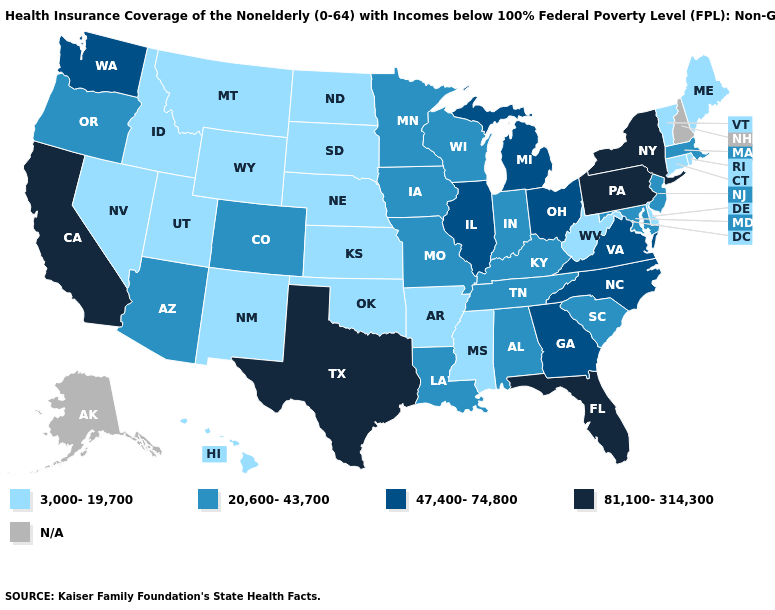What is the value of West Virginia?
Short answer required. 3,000-19,700. Name the states that have a value in the range 20,600-43,700?
Short answer required. Alabama, Arizona, Colorado, Indiana, Iowa, Kentucky, Louisiana, Maryland, Massachusetts, Minnesota, Missouri, New Jersey, Oregon, South Carolina, Tennessee, Wisconsin. Name the states that have a value in the range 20,600-43,700?
Keep it brief. Alabama, Arizona, Colorado, Indiana, Iowa, Kentucky, Louisiana, Maryland, Massachusetts, Minnesota, Missouri, New Jersey, Oregon, South Carolina, Tennessee, Wisconsin. What is the lowest value in the West?
Answer briefly. 3,000-19,700. Which states have the highest value in the USA?
Short answer required. California, Florida, New York, Pennsylvania, Texas. Does Mississippi have the lowest value in the South?
Keep it brief. Yes. Which states have the lowest value in the USA?
Concise answer only. Arkansas, Connecticut, Delaware, Hawaii, Idaho, Kansas, Maine, Mississippi, Montana, Nebraska, Nevada, New Mexico, North Dakota, Oklahoma, Rhode Island, South Dakota, Utah, Vermont, West Virginia, Wyoming. How many symbols are there in the legend?
Give a very brief answer. 5. Among the states that border Arizona , does Utah have the lowest value?
Concise answer only. Yes. What is the value of Hawaii?
Answer briefly. 3,000-19,700. What is the value of Vermont?
Give a very brief answer. 3,000-19,700. What is the value of Oklahoma?
Be succinct. 3,000-19,700. Is the legend a continuous bar?
Be succinct. No. Does the map have missing data?
Be succinct. Yes. 